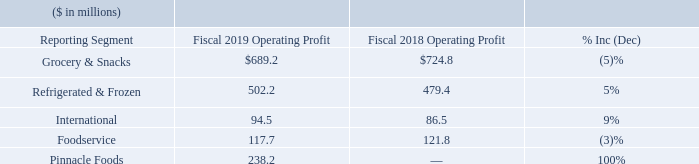Segment Operating Profit (Earnings before general corporate expenses, pension and postretirement non-service income, interest expense, net, income taxes, and equity method investment earnings)
Grocery & Snacks operating profit for fiscal 2019 was $689.2 million, a decrease of $35.6 million, or 5%, compared to fiscal 2018. Gross profits were $55.8 million lower in fiscal 2019 than in fiscal 2018. The lower gross profit was driven by higher input costs, transportation inflation, and a reduction in profit associated with the divestiture of the Wesson ® oil business, partially offset by profit contribution of acquisitions and supply chain realized productivity. The acquisition of Angie's Artisan Treats, LLC contributed $12.6 million to Grocery & Snacks gross profit in fiscal 2019, through the one-year anniversary of the acquisition. Advertising and promotion expenses for fiscal 2019 decreased by $31.3 million compared to fiscal 2018. Operating profit of the Grocery & Snacks segment was impacted by charges totaling $76.5 million in fiscal 2019 for the impairment of our Chef Boyardee® and Red Fork® brand assets and $4.0 million in fiscal 2018 for the impairment of our HK Anderson® , Red Fork® , and Salpica® brand assets. Grocery & Snacks also recognized a $33.1 million gain on the sale of our Wesson ® oil business in fiscal 2019. Operating profit of the Grocery & Snacks segment included $1.0 million and $11.4 million of expenses in fiscal 2019 and 2018, respectively, related to acquisitions and divestitures and charges of $4.6 million and $14.1 million in connection with our restructuring plans in fiscal 2019 and 2018, respectively. Grocery & Snacks operating profit for fiscal 2019 was $689.2 million, a decrease of $35.6 million, or 5%, compared to fiscal 2018. Gross profits were $55.8 million lower in fiscal 2019 than in fiscal 2018. The lower gross profit was driven by higher input costs, transportation inflation, and a reduction in profit associated with the divestiture of the Wesson ® oil business, partially offset by profit contribution of acquisitions and supply chain realized productivity. The acquisition of Angie's Artisan Treats, LLC contributed $12.6 million to Grocery & Snacks gross profit in fiscal 2019, through the one-year anniversary of the acquisition. Advertising and promotion expenses for fiscal 2019 decreased by $31.3 million compared to fiscal 2018. Operating profit of the Grocery & Snacks segment was impacted by charges totaling $76.5 million in fiscal 2019 for the impairment of our Chef Boyardee® and Red Fork® brand assets and $4.0 million in fiscal 2018 for the impairment of our HK Anderson® , Red Fork® , and Salpica® brand assets. Grocery & Snacks also recognized a $33.1 million gain on the sale of our Wesson ® oil business in fiscal 2019. Operating profit of the Grocery & Snacks segment included $1.0 million and $11.4 million of expenses in fiscal 2019 and 2018, respectively, related to acquisitions and divestitures and charges of $4.6 million and $14.1 million in connection with our restructuring plans in fiscal 2019 and 2018, respectively.
Refrigerated & Frozen operating profit for fiscal 2019 was $502.2 million, an increase of $22.8 million, or 5%, compared to fiscal 2018. Gross profits were $19.6 million lower in fiscal 2019 than in fiscal 2018, driven by increased input costs and transportation inflation, partially offset by supply chain realized productivity. Advertising and promotion expenses for fiscal 2019 decreased by $24.6 million compared to fiscal 2018. Operating profit of the Refrigerated & Frozen segment included a gain of $23.1 million in fiscal 2019 related to the sale of our Italian-based frozen pasta business, Gelit.
International operating profit for fiscal 2019 was $94.5 million, an increase of $8.0 million, or 9%, compared to fiscal 2018. Gross profits were flat in fiscal 2019 compared to fiscal 2018. Included in the International segment fiscal 2019 operating profit was a gain of $13.2 million related to the sale of our Del Monte® processed fruit and vegetable business in Canada, charges of $13.1 million for the impairment of our Aylmer® and Sundrop ® brand assets, and charges of $2.9 million related to divestitures. In addition, operating profit was impacted by charges of $1.9 million and $1.5 million in connection with our restructuring plans, in fiscal 2019 and 2018, respectively.
Foodservice operating profit for fiscal 2019 was $117.7 million, a decrease of $4.1 million, or 3%, compared to fiscal 2018. Gross profits were $8.5 million lower in fiscal 2019 than in fiscal 2018, due to lower volume (including the sale of our Trenton, Missouri production facility) and higher input costs, partially offset by supply chain realized productivity
Pinnacle Foods operating profit for fiscal 2019 (reflecting 213 days of Conagra Brands ownership) was $238.2 million. Operating profit for Pinnacle Foods during fiscal 2019 included incremental cost of goods sold of $53.0 million due to the impact of writing inventory to fair value as part of our acquisition accounting and the subsequent sale of that inventory, as well as charges of $5.9 million related to restructuring activities.
What drove the lower gross profit for Grocery & Snacks in the fiscal year 2019 compared to in the fiscal year 2018? Higher input costs, transportation inflation, and a reduction in profit associated with the divestiture of the wesson ® oil business, partially offset by profit contribution of acquisitions and supply chain realized productivity. How much was the sale of the Italian-based frozen pasta business, Gelit, related to the operating profit of the Refrigerated & Frozen segment in the fiscal year 2019? $23.1 million. What was the operating profit  of Foodservice in the fiscal year 2018 and 2019 respectively?
Answer scale should be: million. 121.8, 117.7. What is the proportion of the sale of Del Monte in International’s operating profit in the fiscal year 2019? 13.2/94.5 
Answer: 0.14. What is the proportion of the operating profit in International and Pinnacle Foods over total operating profit in all segments in the fiscal year 2019? (94.5+238.2)/($689.2+502.2+94.5+117.7+238.2) 
Answer: 0.2. What is the percentage change in total operating profit of International and Foodservice from the fiscal year 2018 to 2019?
Answer scale should be: percent. ((94.5+117.7)-(86.5+121.8))/(86.5+121.8) 
Answer: 1.87. 